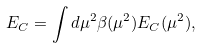Convert formula to latex. <formula><loc_0><loc_0><loc_500><loc_500>E _ { C } = \int d \mu ^ { 2 } \beta ( \mu ^ { 2 } ) E _ { C } ( \mu ^ { 2 } ) ,</formula> 